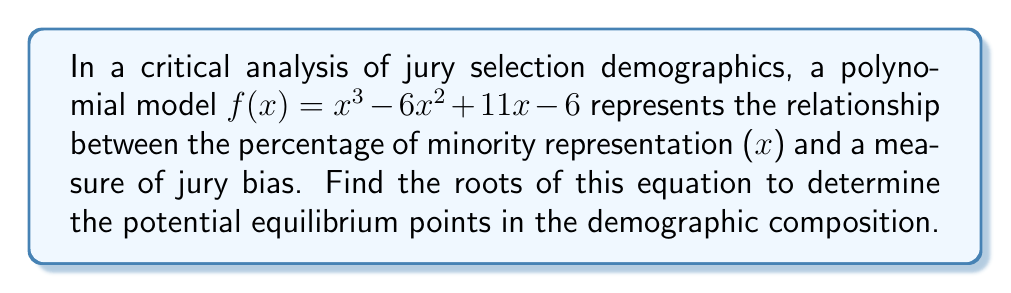Teach me how to tackle this problem. To find the roots of the polynomial $f(x) = x^3 - 6x^2 + 11x - 6$, we'll use factoring techniques:

1) First, let's check if there are any rational roots using the rational root theorem. The potential rational roots are the factors of the constant term: ±1, ±2, ±3, ±6.

2) Testing these values, we find that $f(1) = 0$. So $x = 1$ is a root.

3) We can factor out $(x - 1)$:
   $f(x) = (x - 1)(x^2 - 5x + 6)$

4) The quadratic factor $x^2 - 5x + 6$ can be solved using the quadratic formula or by factoring:
   $x^2 - 5x + 6 = (x - 2)(x - 3)$

5) Therefore, the complete factorization is:
   $f(x) = (x - 1)(x - 2)(x - 3)$

6) The roots are the values that make each factor equal to zero:
   $x = 1, x = 2, x = 3$

These roots represent the equilibrium points in the demographic composition where the measure of jury bias potentially changes direction or reaches a critical value.
Answer: $x = 1, 2, 3$ 